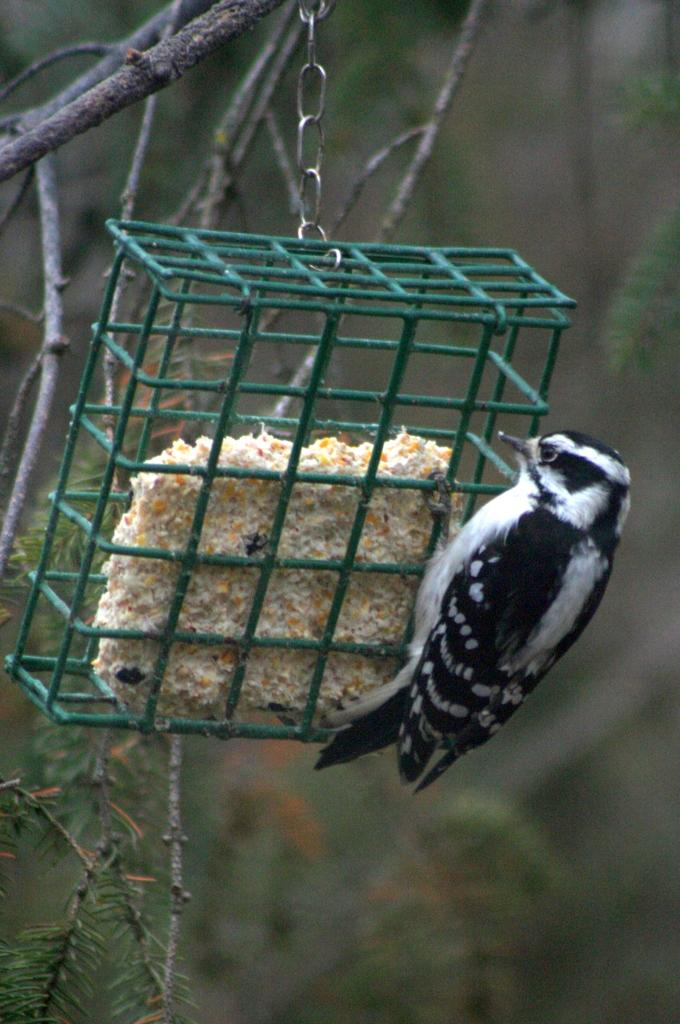What type of animal is in the image? There is a black bird in the image. What is located in the foreground of the image? There is a bird cage in the foreground of the image. What can be seen in the background of the image? There are trees in the background of the image. What are the boys doing in the image? There are no boys present in the image; it features a black bird and a bird cage. What is the bird laughing about in the image? Birds do not have the ability to laugh, and there is no indication of any emotion or action from the bird in the image. 